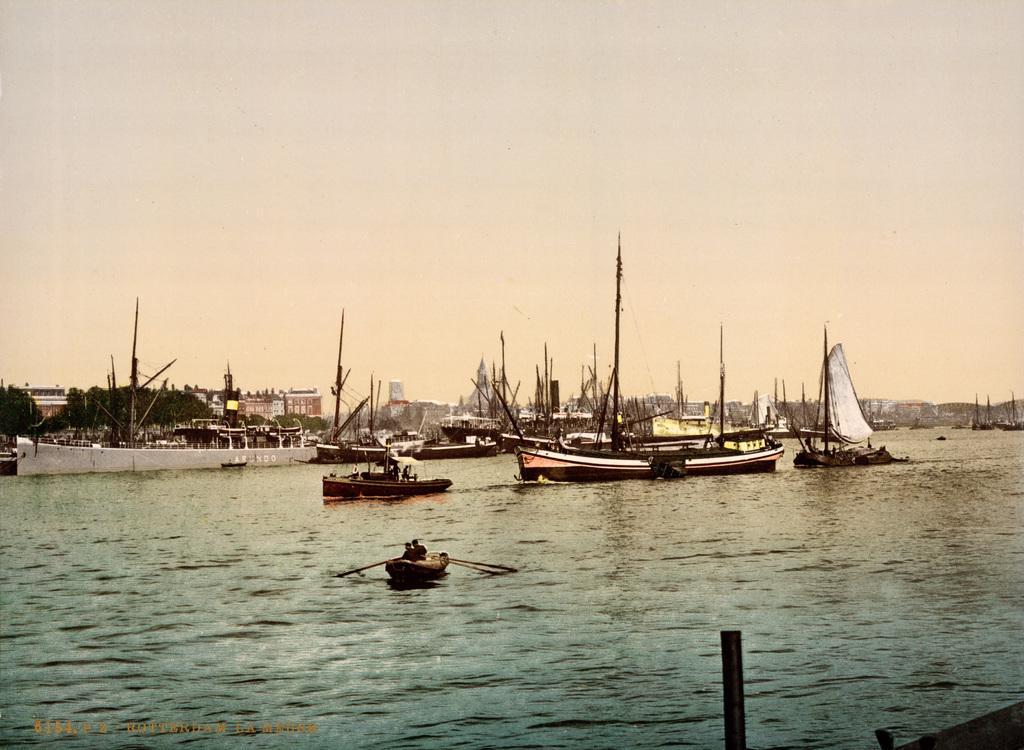Could you give a brief overview of what you see in this image? There are boats on the water. In the background, there are trees, buildings and there is sky. 